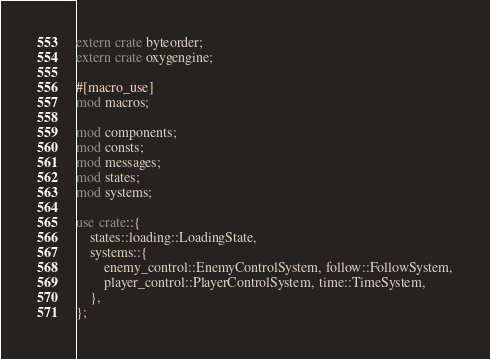<code> <loc_0><loc_0><loc_500><loc_500><_Rust_>extern crate byteorder;
extern crate oxygengine;

#[macro_use]
mod macros;

mod components;
mod consts;
mod messages;
mod states;
mod systems;

use crate::{
    states::loading::LoadingState,
    systems::{
        enemy_control::EnemyControlSystem, follow::FollowSystem,
        player_control::PlayerControlSystem, time::TimeSystem,
    },
};</code> 